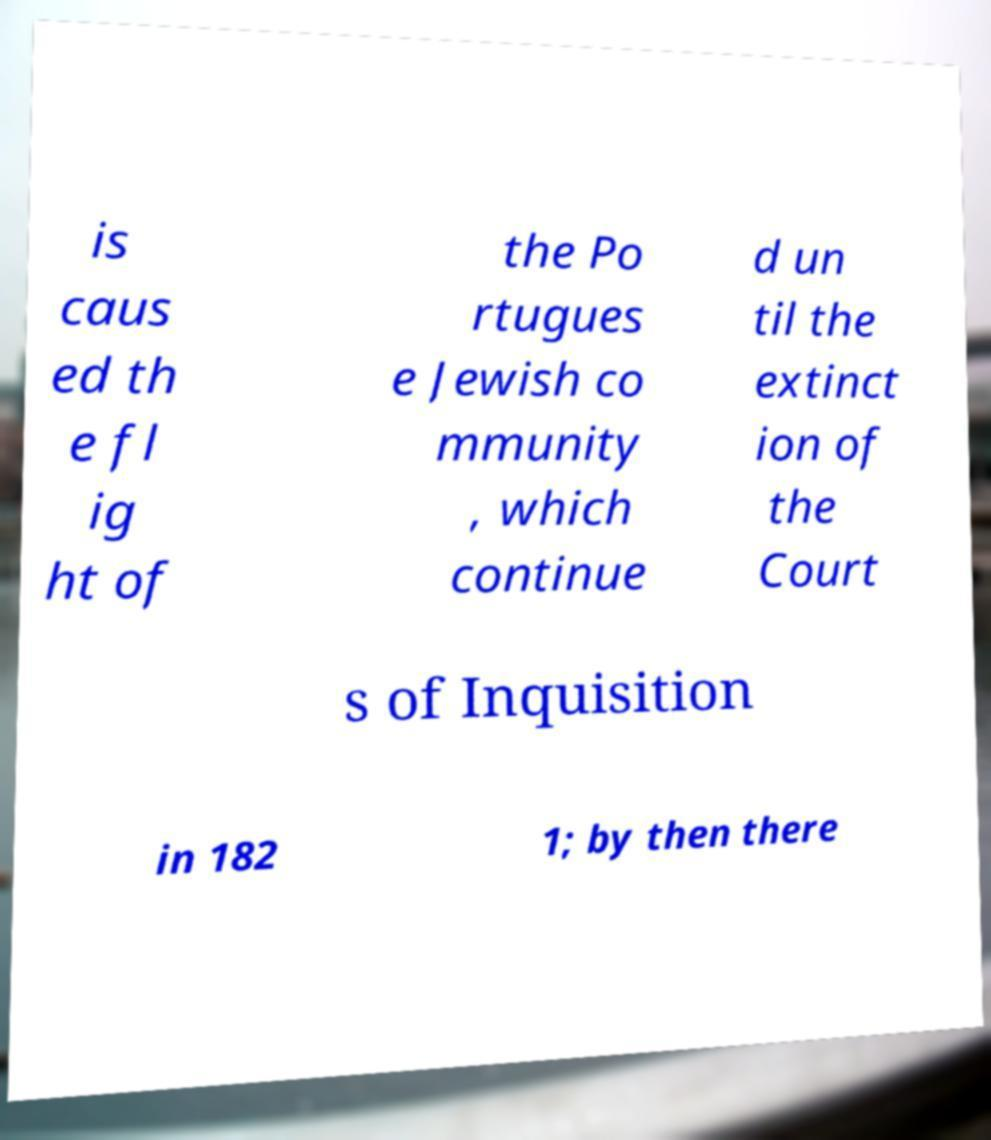There's text embedded in this image that I need extracted. Can you transcribe it verbatim? is caus ed th e fl ig ht of the Po rtugues e Jewish co mmunity , which continue d un til the extinct ion of the Court s of Inquisition in 182 1; by then there 